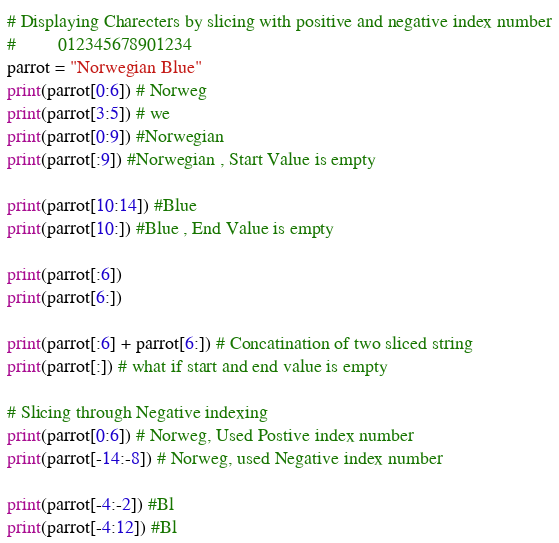Convert code to text. <code><loc_0><loc_0><loc_500><loc_500><_Python_># Displaying Charecters by slicing with positive and negative index number
#         012345678901234
parrot = "Norwegian Blue"
print(parrot[0:6]) # Norweg
print(parrot[3:5]) # we
print(parrot[0:9]) #Norwegian
print(parrot[:9]) #Norwegian , Start Value is empty

print(parrot[10:14]) #Blue
print(parrot[10:]) #Blue , End Value is empty

print(parrot[:6])
print(parrot[6:])

print(parrot[:6] + parrot[6:]) # Concatination of two sliced string
print(parrot[:]) # what if start and end value is empty

# Slicing through Negative indexing
print(parrot[0:6]) # Norweg, Used Postive index number
print(parrot[-14:-8]) # Norweg, used Negative index number

print(parrot[-4:-2]) #Bl 
print(parrot[-4:12]) #Bl







</code> 